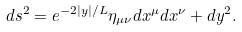Convert formula to latex. <formula><loc_0><loc_0><loc_500><loc_500>d s ^ { 2 } = e ^ { - 2 | y | / L } \eta _ { \mu \nu } d x ^ { \mu } d x ^ { \nu } + d y ^ { 2 } .</formula> 